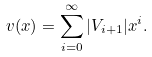<formula> <loc_0><loc_0><loc_500><loc_500>v ( x ) = \sum _ { i = 0 } ^ { \infty } | V _ { i + 1 } | x ^ { i } .</formula> 